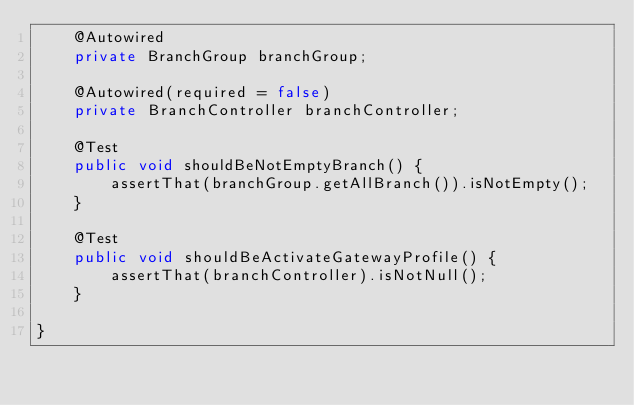Convert code to text. <code><loc_0><loc_0><loc_500><loc_500><_Java_>    @Autowired
    private BranchGroup branchGroup;

    @Autowired(required = false)
    private BranchController branchController;

    @Test
    public void shouldBeNotEmptyBranch() {
        assertThat(branchGroup.getAllBranch()).isNotEmpty();
    }

    @Test
    public void shouldBeActivateGatewayProfile() {
        assertThat(branchController).isNotNull();
    }

}</code> 